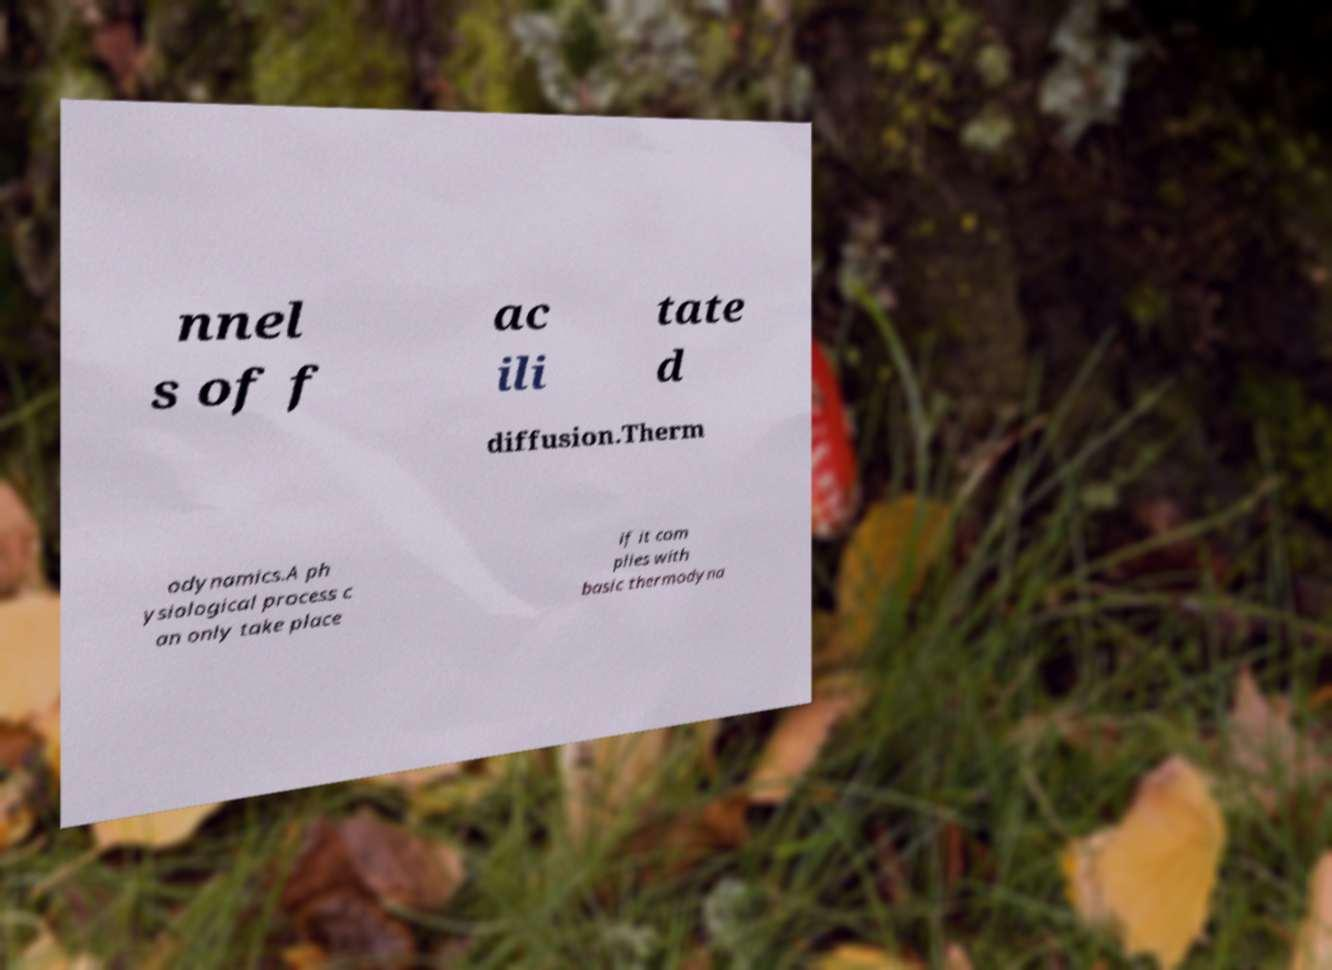I need the written content from this picture converted into text. Can you do that? nnel s of f ac ili tate d diffusion.Therm odynamics.A ph ysiological process c an only take place if it com plies with basic thermodyna 